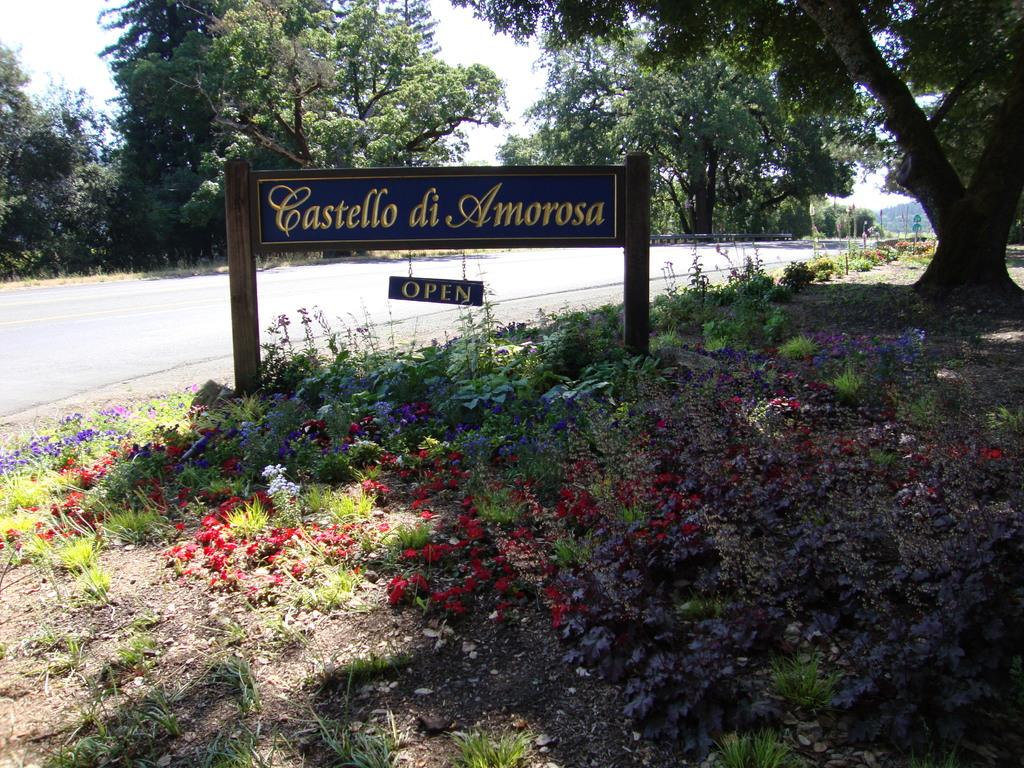What is attached to the wooden surface in the image? There is a board attached to a wooden surface in the image. What colors are the flowers in the image? The flowers in the image are in purple and red colors. What colors are the plants and trees in the image? The plants and trees in the image are in green color. What can be seen in the sky in the image? The sky is visible in the image, and it appears to be white. Can you see any toes in the image? There are no toes visible in the image. What attempt is being made by the plants in the image? The plants in the image are not attempting anything; they are simply growing and being present in the scene. 